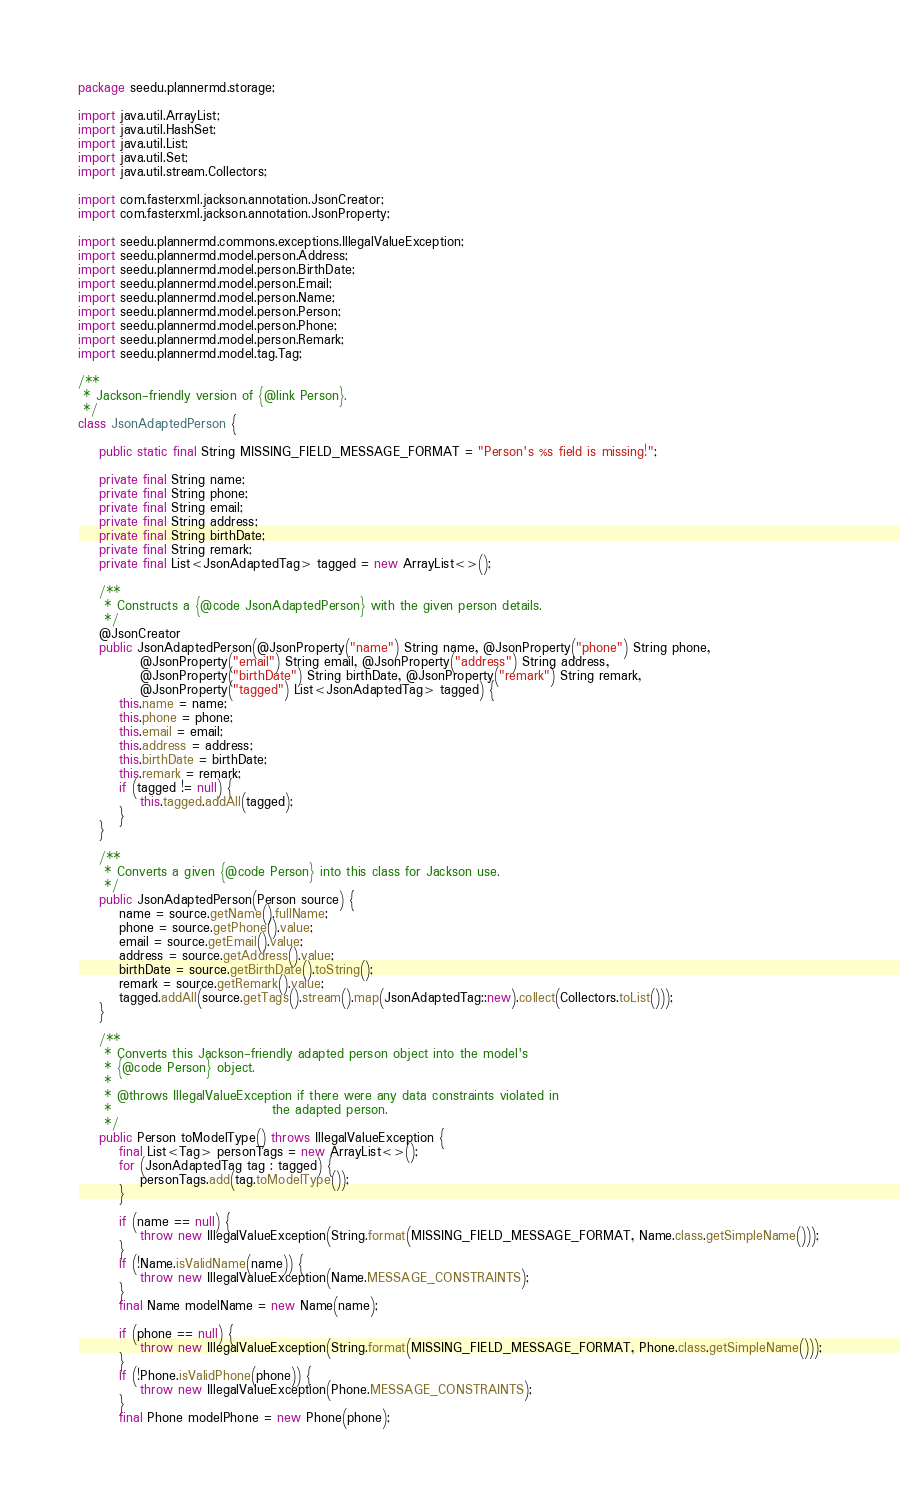<code> <loc_0><loc_0><loc_500><loc_500><_Java_>package seedu.plannermd.storage;

import java.util.ArrayList;
import java.util.HashSet;
import java.util.List;
import java.util.Set;
import java.util.stream.Collectors;

import com.fasterxml.jackson.annotation.JsonCreator;
import com.fasterxml.jackson.annotation.JsonProperty;

import seedu.plannermd.commons.exceptions.IllegalValueException;
import seedu.plannermd.model.person.Address;
import seedu.plannermd.model.person.BirthDate;
import seedu.plannermd.model.person.Email;
import seedu.plannermd.model.person.Name;
import seedu.plannermd.model.person.Person;
import seedu.plannermd.model.person.Phone;
import seedu.plannermd.model.person.Remark;
import seedu.plannermd.model.tag.Tag;

/**
 * Jackson-friendly version of {@link Person}.
 */
class JsonAdaptedPerson {

    public static final String MISSING_FIELD_MESSAGE_FORMAT = "Person's %s field is missing!";

    private final String name;
    private final String phone;
    private final String email;
    private final String address;
    private final String birthDate;
    private final String remark;
    private final List<JsonAdaptedTag> tagged = new ArrayList<>();

    /**
     * Constructs a {@code JsonAdaptedPerson} with the given person details.
     */
    @JsonCreator
    public JsonAdaptedPerson(@JsonProperty("name") String name, @JsonProperty("phone") String phone,
            @JsonProperty("email") String email, @JsonProperty("address") String address,
            @JsonProperty("birthDate") String birthDate, @JsonProperty("remark") String remark,
            @JsonProperty("tagged") List<JsonAdaptedTag> tagged) {
        this.name = name;
        this.phone = phone;
        this.email = email;
        this.address = address;
        this.birthDate = birthDate;
        this.remark = remark;
        if (tagged != null) {
            this.tagged.addAll(tagged);
        }
    }

    /**
     * Converts a given {@code Person} into this class for Jackson use.
     */
    public JsonAdaptedPerson(Person source) {
        name = source.getName().fullName;
        phone = source.getPhone().value;
        email = source.getEmail().value;
        address = source.getAddress().value;
        birthDate = source.getBirthDate().toString();
        remark = source.getRemark().value;
        tagged.addAll(source.getTags().stream().map(JsonAdaptedTag::new).collect(Collectors.toList()));
    }

    /**
     * Converts this Jackson-friendly adapted person object into the model's
     * {@code Person} object.
     *
     * @throws IllegalValueException if there were any data constraints violated in
     *                               the adapted person.
     */
    public Person toModelType() throws IllegalValueException {
        final List<Tag> personTags = new ArrayList<>();
        for (JsonAdaptedTag tag : tagged) {
            personTags.add(tag.toModelType());
        }

        if (name == null) {
            throw new IllegalValueException(String.format(MISSING_FIELD_MESSAGE_FORMAT, Name.class.getSimpleName()));
        }
        if (!Name.isValidName(name)) {
            throw new IllegalValueException(Name.MESSAGE_CONSTRAINTS);
        }
        final Name modelName = new Name(name);

        if (phone == null) {
            throw new IllegalValueException(String.format(MISSING_FIELD_MESSAGE_FORMAT, Phone.class.getSimpleName()));
        }
        if (!Phone.isValidPhone(phone)) {
            throw new IllegalValueException(Phone.MESSAGE_CONSTRAINTS);
        }
        final Phone modelPhone = new Phone(phone);
</code> 